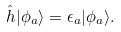Convert formula to latex. <formula><loc_0><loc_0><loc_500><loc_500>\hat { h } | \phi _ { a } \rangle = \epsilon _ { a } | \phi _ { a } \rangle .</formula> 